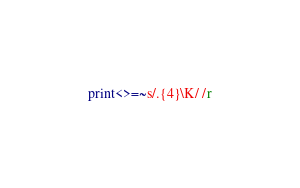<code> <loc_0><loc_0><loc_500><loc_500><_Perl_>print<>=~s/.{4}\K/ /r</code> 